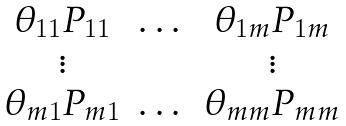<formula> <loc_0><loc_0><loc_500><loc_500>\begin{matrix} \theta _ { 1 1 } P _ { 1 1 } & \dots & \theta _ { 1 m } P _ { 1 m } \\ \vdots & & \vdots \\ \theta _ { m 1 } P _ { m 1 } & \dots & \theta _ { m m } P _ { m m } \end{matrix}</formula> 